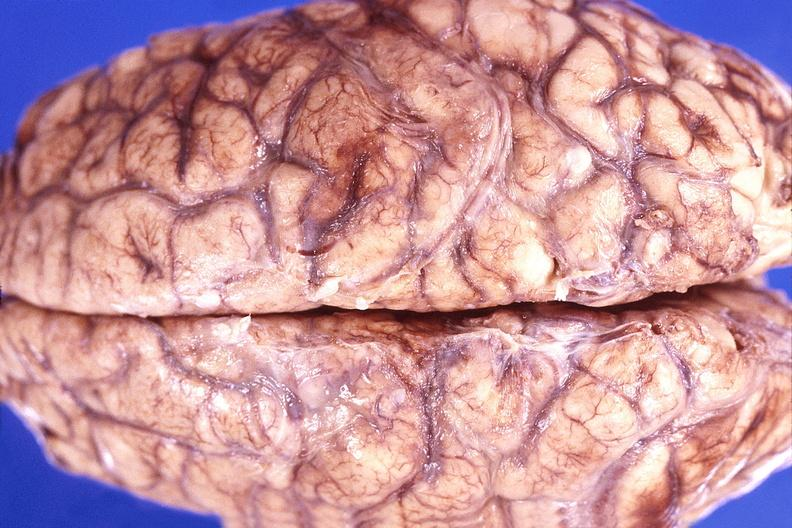what does this image show?
Answer the question using a single word or phrase. Brain abscess 